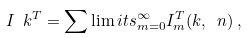Convert formula to latex. <formula><loc_0><loc_0><loc_500><loc_500>I _ { \ } k ^ { T } = \sum \lim i t s _ { m = 0 } ^ { \infty } I _ { m } ^ { T } ( k , \ n ) \, ,</formula> 